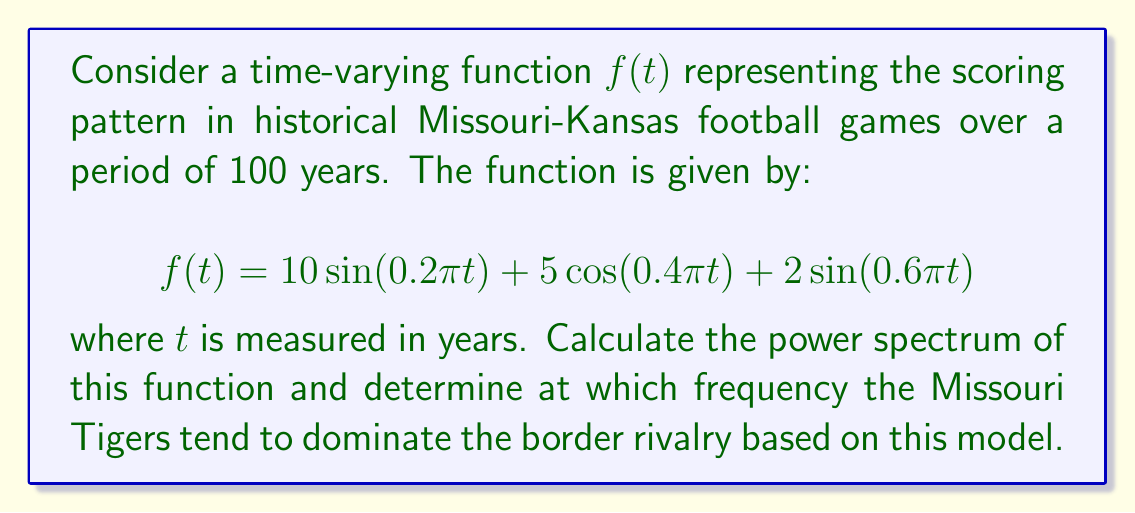Give your solution to this math problem. To analyze the power spectrum of the given time-varying function, we need to follow these steps:

1) First, recall that the power spectrum is proportional to the square of the magnitude of the Fourier transform of the function.

2) For a function of the form $A \sin(\omega t)$ or $A \cos(\omega t)$, the Fourier transform will have peaks at frequencies $\pm \omega/(2\pi)$.

3) Let's identify the frequencies in our function:
   - $0.2\pi t$ corresponds to a frequency of $0.1$ cycles per year
   - $0.4\pi t$ corresponds to a frequency of $0.2$ cycles per year
   - $0.6\pi t$ corresponds to a frequency of $0.3$ cycles per year

4) The amplitude of each component in the Fourier transform will be proportional to the coefficient in the time domain:
   - $10$ for the $0.1$ cycles/year component
   - $5$ for the $0.2$ cycles/year component
   - $2$ for the $0.3$ cycles/year component

5) The power spectrum is proportional to the square of these amplitudes:
   - $10^2 = 100$ for the $0.1$ cycles/year component
   - $5^2 = 25$ for the $0.2$ cycles/year component
   - $2^2 = 4$ for the $0.3$ cycles/year component

6) The highest peak in the power spectrum corresponds to the dominant frequency in the signal.

7) In this case, the highest peak is at $0.1$ cycles per year, with a power of 100.

Therefore, based on this model, the Missouri Tigers tend to dominate the border rivalry at a frequency of 0.1 cycles per year, or once every 10 years.
Answer: The Missouri Tigers tend to dominate the border rivalry at a frequency of 0.1 cycles per year (once every 10 years) based on the given model. 